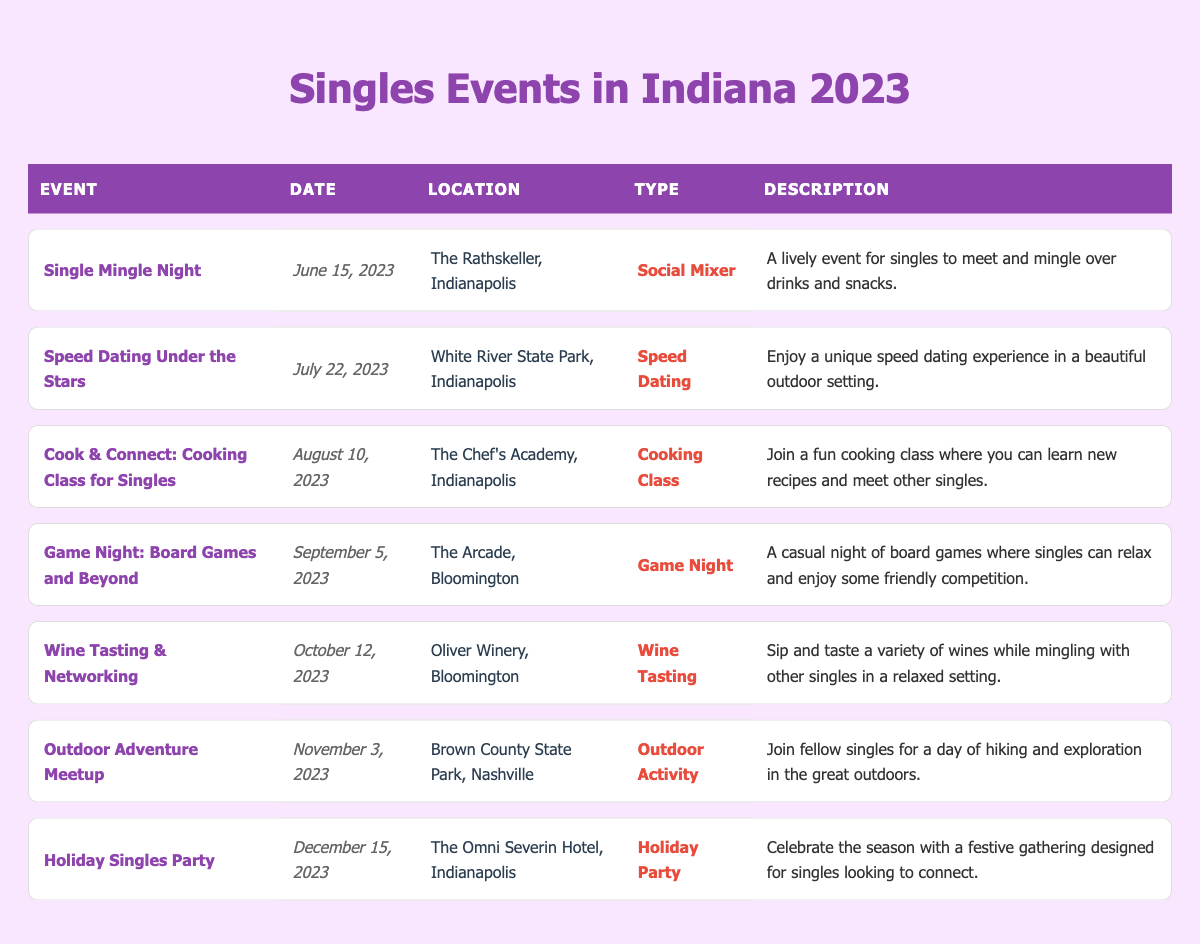What is the date of the "Single Mingle Night" event? The "Single Mingle Night" event is highlighted in the table, and its date is listed next to the event name. According to the table, it is on June 15, 2023.
Answer: June 15, 2023 Where is the "Holiday Singles Party" being held? The "Holiday Singles Party" is another highlighted event. By checking the corresponding location in the table, it is revealed that the event will take place at The Omni Severin Hotel in Indianapolis.
Answer: The Omni Severin Hotel, Indianapolis How many events are scheduled for August 2023? Only one entry in the table is for August, which is the "Cook & Connect: Cooking Class for Singles" on August 10, 2023. Therefore, there is one event for that month.
Answer: 1 What type of event is scheduled for October 12, 2023? Referring to the table, the event on October 12, 2023, is "Wine Tasting & Networking." The type of this event is specifically labeled as a "Wine Tasting."
Answer: Wine Tasting Is there a speed dating event taking place in 2023? Looking through the table, there is indeed a speed dating event listed. It is called "Speed Dating Under the Stars," scheduled for July 22, 2023. Therefore, the answer is yes.
Answer: Yes Which event has the location of Brown County State Park? Only one event has this location, which is for the "Outdoor Adventure Meetup." Checking the table confirms this event is set for November 3, 2023.
Answer: Outdoor Adventure Meetup What is the total number of highlighted events listed? By counting the rows colored as highlighted in the table, there are four highlighted events: "Single Mingle Night," "Cook & Connect: Cooking Class for Singles," "Wine Tasting & Networking," and "Holiday Singles Party."
Answer: 4 Which month has the greatest number of events listed? Inspecting the table reveals that June, August, and December each have one highlighted event while other months, such as July and October, have one event each that is not highlighted. Thus, all months have the same number of events at this level of detail.
Answer: Tie (all have the same) What type of event is the "Cook & Connect: Cooking Class for Singles," and what date does it occur? The "Cook & Connect: Cooking Class for Singles" type is found by checking the events section, and it is classified as a "Cooking Class." It is scheduled for August 10, 2023, according to the date column.
Answer: Cooking Class, August 10, 2023 Which highlighted event occurs last in the year? The last highlighted event in the table is the "Holiday Singles Party" on December 15, 2023. By reviewing the dates of all highlighted events, this one is the latest in the year.
Answer: Holiday Singles Party on December 15, 2023 